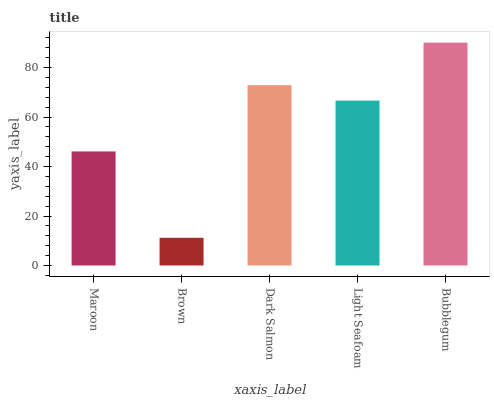Is Brown the minimum?
Answer yes or no. Yes. Is Bubblegum the maximum?
Answer yes or no. Yes. Is Dark Salmon the minimum?
Answer yes or no. No. Is Dark Salmon the maximum?
Answer yes or no. No. Is Dark Salmon greater than Brown?
Answer yes or no. Yes. Is Brown less than Dark Salmon?
Answer yes or no. Yes. Is Brown greater than Dark Salmon?
Answer yes or no. No. Is Dark Salmon less than Brown?
Answer yes or no. No. Is Light Seafoam the high median?
Answer yes or no. Yes. Is Light Seafoam the low median?
Answer yes or no. Yes. Is Maroon the high median?
Answer yes or no. No. Is Brown the low median?
Answer yes or no. No. 